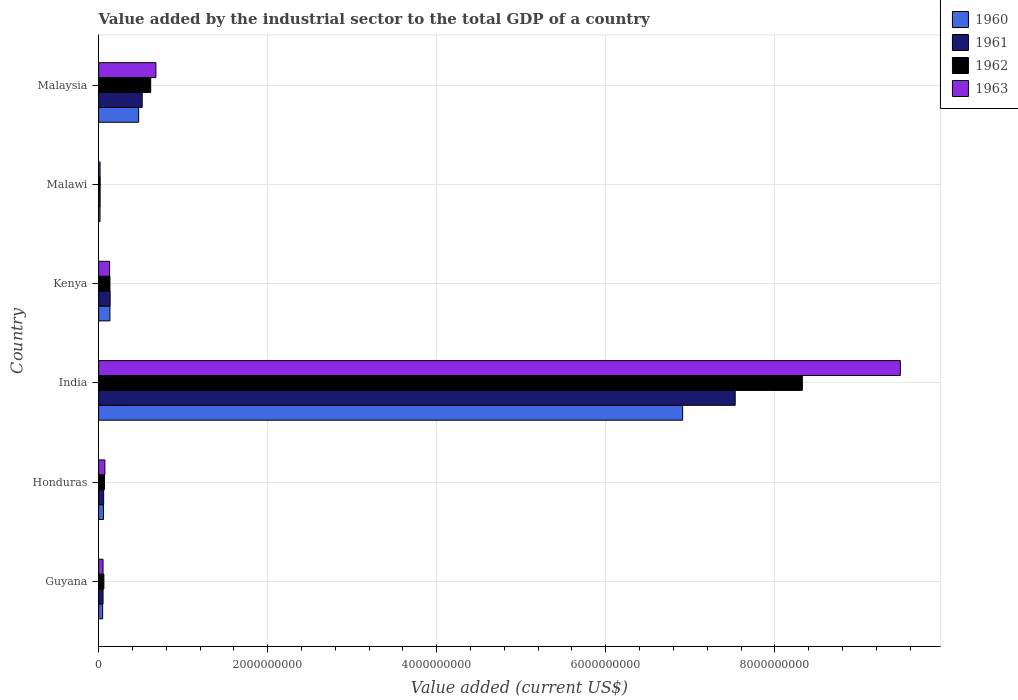How many different coloured bars are there?
Your response must be concise. 4. How many bars are there on the 1st tick from the top?
Give a very brief answer. 4. How many bars are there on the 1st tick from the bottom?
Make the answer very short. 4. What is the label of the 5th group of bars from the top?
Provide a short and direct response. Honduras. What is the value added by the industrial sector to the total GDP in 1962 in India?
Provide a short and direct response. 8.33e+09. Across all countries, what is the maximum value added by the industrial sector to the total GDP in 1962?
Offer a terse response. 8.33e+09. Across all countries, what is the minimum value added by the industrial sector to the total GDP in 1960?
Your answer should be compact. 1.62e+07. In which country was the value added by the industrial sector to the total GDP in 1960 minimum?
Your answer should be compact. Malawi. What is the total value added by the industrial sector to the total GDP in 1963 in the graph?
Provide a succinct answer. 1.04e+1. What is the difference between the value added by the industrial sector to the total GDP in 1962 in Guyana and that in Kenya?
Keep it short and to the point. -7.19e+07. What is the difference between the value added by the industrial sector to the total GDP in 1960 in Guyana and the value added by the industrial sector to the total GDP in 1962 in Honduras?
Ensure brevity in your answer.  -2.18e+07. What is the average value added by the industrial sector to the total GDP in 1961 per country?
Ensure brevity in your answer.  1.39e+09. What is the difference between the value added by the industrial sector to the total GDP in 1960 and value added by the industrial sector to the total GDP in 1962 in Malawi?
Your answer should be very brief. -1.54e+06. In how many countries, is the value added by the industrial sector to the total GDP in 1963 greater than 8400000000 US$?
Offer a terse response. 1. What is the ratio of the value added by the industrial sector to the total GDP in 1962 in Honduras to that in Malawi?
Offer a very short reply. 3.89. What is the difference between the highest and the second highest value added by the industrial sector to the total GDP in 1962?
Ensure brevity in your answer.  7.71e+09. What is the difference between the highest and the lowest value added by the industrial sector to the total GDP in 1962?
Provide a succinct answer. 8.31e+09. Is the sum of the value added by the industrial sector to the total GDP in 1960 in Kenya and Malaysia greater than the maximum value added by the industrial sector to the total GDP in 1963 across all countries?
Your answer should be very brief. No. What does the 3rd bar from the top in Malawi represents?
Provide a succinct answer. 1961. Is it the case that in every country, the sum of the value added by the industrial sector to the total GDP in 1960 and value added by the industrial sector to the total GDP in 1961 is greater than the value added by the industrial sector to the total GDP in 1963?
Make the answer very short. Yes. How many bars are there?
Make the answer very short. 24. Are all the bars in the graph horizontal?
Ensure brevity in your answer.  Yes. How many countries are there in the graph?
Give a very brief answer. 6. Are the values on the major ticks of X-axis written in scientific E-notation?
Provide a short and direct response. No. Where does the legend appear in the graph?
Your response must be concise. Top right. How many legend labels are there?
Ensure brevity in your answer.  4. What is the title of the graph?
Offer a very short reply. Value added by the industrial sector to the total GDP of a country. Does "1998" appear as one of the legend labels in the graph?
Keep it short and to the point. No. What is the label or title of the X-axis?
Offer a very short reply. Value added (current US$). What is the Value added (current US$) in 1960 in Guyana?
Your answer should be compact. 4.74e+07. What is the Value added (current US$) of 1961 in Guyana?
Give a very brief answer. 5.23e+07. What is the Value added (current US$) in 1962 in Guyana?
Provide a succinct answer. 6.20e+07. What is the Value added (current US$) in 1963 in Guyana?
Your answer should be compact. 5.21e+07. What is the Value added (current US$) in 1960 in Honduras?
Your answer should be very brief. 5.73e+07. What is the Value added (current US$) in 1961 in Honduras?
Offer a terse response. 5.94e+07. What is the Value added (current US$) in 1962 in Honduras?
Offer a very short reply. 6.92e+07. What is the Value added (current US$) in 1963 in Honduras?
Give a very brief answer. 7.38e+07. What is the Value added (current US$) of 1960 in India?
Provide a succinct answer. 6.91e+09. What is the Value added (current US$) in 1961 in India?
Ensure brevity in your answer.  7.53e+09. What is the Value added (current US$) in 1962 in India?
Provide a succinct answer. 8.33e+09. What is the Value added (current US$) of 1963 in India?
Provide a succinct answer. 9.49e+09. What is the Value added (current US$) in 1960 in Kenya?
Offer a very short reply. 1.34e+08. What is the Value added (current US$) in 1961 in Kenya?
Your response must be concise. 1.36e+08. What is the Value added (current US$) of 1962 in Kenya?
Your answer should be very brief. 1.34e+08. What is the Value added (current US$) in 1963 in Kenya?
Provide a succinct answer. 1.30e+08. What is the Value added (current US$) in 1960 in Malawi?
Provide a succinct answer. 1.62e+07. What is the Value added (current US$) of 1961 in Malawi?
Offer a terse response. 1.76e+07. What is the Value added (current US$) in 1962 in Malawi?
Provide a short and direct response. 1.78e+07. What is the Value added (current US$) in 1963 in Malawi?
Your answer should be very brief. 1.69e+07. What is the Value added (current US$) of 1960 in Malaysia?
Your answer should be very brief. 4.74e+08. What is the Value added (current US$) of 1961 in Malaysia?
Provide a succinct answer. 5.15e+08. What is the Value added (current US$) in 1962 in Malaysia?
Offer a very short reply. 6.16e+08. What is the Value added (current US$) in 1963 in Malaysia?
Offer a terse response. 6.77e+08. Across all countries, what is the maximum Value added (current US$) of 1960?
Provide a succinct answer. 6.91e+09. Across all countries, what is the maximum Value added (current US$) in 1961?
Make the answer very short. 7.53e+09. Across all countries, what is the maximum Value added (current US$) of 1962?
Offer a terse response. 8.33e+09. Across all countries, what is the maximum Value added (current US$) of 1963?
Ensure brevity in your answer.  9.49e+09. Across all countries, what is the minimum Value added (current US$) in 1960?
Keep it short and to the point. 1.62e+07. Across all countries, what is the minimum Value added (current US$) of 1961?
Ensure brevity in your answer.  1.76e+07. Across all countries, what is the minimum Value added (current US$) of 1962?
Your response must be concise. 1.78e+07. Across all countries, what is the minimum Value added (current US$) of 1963?
Keep it short and to the point. 1.69e+07. What is the total Value added (current US$) of 1960 in the graph?
Your answer should be compact. 7.64e+09. What is the total Value added (current US$) in 1961 in the graph?
Offer a terse response. 8.31e+09. What is the total Value added (current US$) of 1962 in the graph?
Keep it short and to the point. 9.22e+09. What is the total Value added (current US$) in 1963 in the graph?
Keep it short and to the point. 1.04e+1. What is the difference between the Value added (current US$) in 1960 in Guyana and that in Honduras?
Make the answer very short. -9.88e+06. What is the difference between the Value added (current US$) in 1961 in Guyana and that in Honduras?
Offer a terse response. -7.08e+06. What is the difference between the Value added (current US$) in 1962 in Guyana and that in Honduras?
Your answer should be very brief. -7.19e+06. What is the difference between the Value added (current US$) in 1963 in Guyana and that in Honduras?
Your answer should be very brief. -2.17e+07. What is the difference between the Value added (current US$) in 1960 in Guyana and that in India?
Provide a succinct answer. -6.86e+09. What is the difference between the Value added (current US$) in 1961 in Guyana and that in India?
Your answer should be very brief. -7.48e+09. What is the difference between the Value added (current US$) of 1962 in Guyana and that in India?
Provide a short and direct response. -8.26e+09. What is the difference between the Value added (current US$) of 1963 in Guyana and that in India?
Provide a short and direct response. -9.43e+09. What is the difference between the Value added (current US$) of 1960 in Guyana and that in Kenya?
Your answer should be very brief. -8.62e+07. What is the difference between the Value added (current US$) in 1961 in Guyana and that in Kenya?
Offer a terse response. -8.36e+07. What is the difference between the Value added (current US$) in 1962 in Guyana and that in Kenya?
Your answer should be compact. -7.19e+07. What is the difference between the Value added (current US$) in 1963 in Guyana and that in Kenya?
Give a very brief answer. -7.74e+07. What is the difference between the Value added (current US$) of 1960 in Guyana and that in Malawi?
Make the answer very short. 3.12e+07. What is the difference between the Value added (current US$) in 1961 in Guyana and that in Malawi?
Give a very brief answer. 3.46e+07. What is the difference between the Value added (current US$) in 1962 in Guyana and that in Malawi?
Ensure brevity in your answer.  4.42e+07. What is the difference between the Value added (current US$) in 1963 in Guyana and that in Malawi?
Provide a short and direct response. 3.52e+07. What is the difference between the Value added (current US$) in 1960 in Guyana and that in Malaysia?
Your response must be concise. -4.26e+08. What is the difference between the Value added (current US$) of 1961 in Guyana and that in Malaysia?
Offer a very short reply. -4.63e+08. What is the difference between the Value added (current US$) of 1962 in Guyana and that in Malaysia?
Your answer should be very brief. -5.54e+08. What is the difference between the Value added (current US$) of 1963 in Guyana and that in Malaysia?
Give a very brief answer. -6.25e+08. What is the difference between the Value added (current US$) of 1960 in Honduras and that in India?
Your response must be concise. -6.85e+09. What is the difference between the Value added (current US$) of 1961 in Honduras and that in India?
Provide a succinct answer. -7.47e+09. What is the difference between the Value added (current US$) in 1962 in Honduras and that in India?
Ensure brevity in your answer.  -8.26e+09. What is the difference between the Value added (current US$) of 1963 in Honduras and that in India?
Make the answer very short. -9.41e+09. What is the difference between the Value added (current US$) of 1960 in Honduras and that in Kenya?
Provide a short and direct response. -7.63e+07. What is the difference between the Value added (current US$) in 1961 in Honduras and that in Kenya?
Ensure brevity in your answer.  -7.65e+07. What is the difference between the Value added (current US$) in 1962 in Honduras and that in Kenya?
Offer a terse response. -6.47e+07. What is the difference between the Value added (current US$) of 1963 in Honduras and that in Kenya?
Make the answer very short. -5.57e+07. What is the difference between the Value added (current US$) in 1960 in Honduras and that in Malawi?
Ensure brevity in your answer.  4.11e+07. What is the difference between the Value added (current US$) in 1961 in Honduras and that in Malawi?
Ensure brevity in your answer.  4.17e+07. What is the difference between the Value added (current US$) of 1962 in Honduras and that in Malawi?
Your answer should be compact. 5.14e+07. What is the difference between the Value added (current US$) in 1963 in Honduras and that in Malawi?
Provide a short and direct response. 5.69e+07. What is the difference between the Value added (current US$) of 1960 in Honduras and that in Malaysia?
Provide a short and direct response. -4.16e+08. What is the difference between the Value added (current US$) of 1961 in Honduras and that in Malaysia?
Give a very brief answer. -4.56e+08. What is the difference between the Value added (current US$) of 1962 in Honduras and that in Malaysia?
Your answer should be compact. -5.47e+08. What is the difference between the Value added (current US$) in 1963 in Honduras and that in Malaysia?
Offer a terse response. -6.04e+08. What is the difference between the Value added (current US$) in 1960 in India and that in Kenya?
Give a very brief answer. 6.78e+09. What is the difference between the Value added (current US$) of 1961 in India and that in Kenya?
Keep it short and to the point. 7.40e+09. What is the difference between the Value added (current US$) of 1962 in India and that in Kenya?
Ensure brevity in your answer.  8.19e+09. What is the difference between the Value added (current US$) of 1963 in India and that in Kenya?
Make the answer very short. 9.36e+09. What is the difference between the Value added (current US$) of 1960 in India and that in Malawi?
Your response must be concise. 6.89e+09. What is the difference between the Value added (current US$) in 1961 in India and that in Malawi?
Keep it short and to the point. 7.51e+09. What is the difference between the Value added (current US$) in 1962 in India and that in Malawi?
Offer a very short reply. 8.31e+09. What is the difference between the Value added (current US$) of 1963 in India and that in Malawi?
Provide a short and direct response. 9.47e+09. What is the difference between the Value added (current US$) in 1960 in India and that in Malaysia?
Ensure brevity in your answer.  6.44e+09. What is the difference between the Value added (current US$) in 1961 in India and that in Malaysia?
Offer a very short reply. 7.02e+09. What is the difference between the Value added (current US$) in 1962 in India and that in Malaysia?
Ensure brevity in your answer.  7.71e+09. What is the difference between the Value added (current US$) in 1963 in India and that in Malaysia?
Make the answer very short. 8.81e+09. What is the difference between the Value added (current US$) of 1960 in Kenya and that in Malawi?
Make the answer very short. 1.17e+08. What is the difference between the Value added (current US$) of 1961 in Kenya and that in Malawi?
Keep it short and to the point. 1.18e+08. What is the difference between the Value added (current US$) of 1962 in Kenya and that in Malawi?
Make the answer very short. 1.16e+08. What is the difference between the Value added (current US$) of 1963 in Kenya and that in Malawi?
Your answer should be compact. 1.13e+08. What is the difference between the Value added (current US$) in 1960 in Kenya and that in Malaysia?
Give a very brief answer. -3.40e+08. What is the difference between the Value added (current US$) in 1961 in Kenya and that in Malaysia?
Offer a very short reply. -3.79e+08. What is the difference between the Value added (current US$) of 1962 in Kenya and that in Malaysia?
Keep it short and to the point. -4.82e+08. What is the difference between the Value added (current US$) in 1963 in Kenya and that in Malaysia?
Your answer should be compact. -5.48e+08. What is the difference between the Value added (current US$) of 1960 in Malawi and that in Malaysia?
Your response must be concise. -4.57e+08. What is the difference between the Value added (current US$) of 1961 in Malawi and that in Malaysia?
Ensure brevity in your answer.  -4.98e+08. What is the difference between the Value added (current US$) of 1962 in Malawi and that in Malaysia?
Make the answer very short. -5.98e+08. What is the difference between the Value added (current US$) of 1963 in Malawi and that in Malaysia?
Make the answer very short. -6.61e+08. What is the difference between the Value added (current US$) in 1960 in Guyana and the Value added (current US$) in 1961 in Honduras?
Ensure brevity in your answer.  -1.19e+07. What is the difference between the Value added (current US$) of 1960 in Guyana and the Value added (current US$) of 1962 in Honduras?
Make the answer very short. -2.18e+07. What is the difference between the Value added (current US$) in 1960 in Guyana and the Value added (current US$) in 1963 in Honduras?
Your answer should be very brief. -2.64e+07. What is the difference between the Value added (current US$) in 1961 in Guyana and the Value added (current US$) in 1962 in Honduras?
Your answer should be very brief. -1.69e+07. What is the difference between the Value added (current US$) in 1961 in Guyana and the Value added (current US$) in 1963 in Honduras?
Your response must be concise. -2.15e+07. What is the difference between the Value added (current US$) in 1962 in Guyana and the Value added (current US$) in 1963 in Honduras?
Keep it short and to the point. -1.18e+07. What is the difference between the Value added (current US$) in 1960 in Guyana and the Value added (current US$) in 1961 in India?
Offer a terse response. -7.48e+09. What is the difference between the Value added (current US$) in 1960 in Guyana and the Value added (current US$) in 1962 in India?
Provide a succinct answer. -8.28e+09. What is the difference between the Value added (current US$) in 1960 in Guyana and the Value added (current US$) in 1963 in India?
Your response must be concise. -9.44e+09. What is the difference between the Value added (current US$) in 1961 in Guyana and the Value added (current US$) in 1962 in India?
Give a very brief answer. -8.27e+09. What is the difference between the Value added (current US$) of 1961 in Guyana and the Value added (current US$) of 1963 in India?
Provide a succinct answer. -9.43e+09. What is the difference between the Value added (current US$) in 1962 in Guyana and the Value added (current US$) in 1963 in India?
Make the answer very short. -9.42e+09. What is the difference between the Value added (current US$) of 1960 in Guyana and the Value added (current US$) of 1961 in Kenya?
Provide a succinct answer. -8.85e+07. What is the difference between the Value added (current US$) in 1960 in Guyana and the Value added (current US$) in 1962 in Kenya?
Offer a very short reply. -8.65e+07. What is the difference between the Value added (current US$) in 1960 in Guyana and the Value added (current US$) in 1963 in Kenya?
Offer a terse response. -8.21e+07. What is the difference between the Value added (current US$) of 1961 in Guyana and the Value added (current US$) of 1962 in Kenya?
Offer a very short reply. -8.17e+07. What is the difference between the Value added (current US$) of 1961 in Guyana and the Value added (current US$) of 1963 in Kenya?
Your response must be concise. -7.73e+07. What is the difference between the Value added (current US$) in 1962 in Guyana and the Value added (current US$) in 1963 in Kenya?
Offer a terse response. -6.75e+07. What is the difference between the Value added (current US$) of 1960 in Guyana and the Value added (current US$) of 1961 in Malawi?
Ensure brevity in your answer.  2.98e+07. What is the difference between the Value added (current US$) in 1960 in Guyana and the Value added (current US$) in 1962 in Malawi?
Offer a very short reply. 2.96e+07. What is the difference between the Value added (current US$) of 1960 in Guyana and the Value added (current US$) of 1963 in Malawi?
Offer a terse response. 3.05e+07. What is the difference between the Value added (current US$) in 1961 in Guyana and the Value added (current US$) in 1962 in Malawi?
Give a very brief answer. 3.45e+07. What is the difference between the Value added (current US$) of 1961 in Guyana and the Value added (current US$) of 1963 in Malawi?
Provide a short and direct response. 3.53e+07. What is the difference between the Value added (current US$) of 1962 in Guyana and the Value added (current US$) of 1963 in Malawi?
Offer a terse response. 4.51e+07. What is the difference between the Value added (current US$) of 1960 in Guyana and the Value added (current US$) of 1961 in Malaysia?
Give a very brief answer. -4.68e+08. What is the difference between the Value added (current US$) in 1960 in Guyana and the Value added (current US$) in 1962 in Malaysia?
Provide a short and direct response. -5.69e+08. What is the difference between the Value added (current US$) of 1960 in Guyana and the Value added (current US$) of 1963 in Malaysia?
Provide a succinct answer. -6.30e+08. What is the difference between the Value added (current US$) in 1961 in Guyana and the Value added (current US$) in 1962 in Malaysia?
Ensure brevity in your answer.  -5.64e+08. What is the difference between the Value added (current US$) of 1961 in Guyana and the Value added (current US$) of 1963 in Malaysia?
Offer a terse response. -6.25e+08. What is the difference between the Value added (current US$) of 1962 in Guyana and the Value added (current US$) of 1963 in Malaysia?
Offer a very short reply. -6.15e+08. What is the difference between the Value added (current US$) in 1960 in Honduras and the Value added (current US$) in 1961 in India?
Offer a very short reply. -7.47e+09. What is the difference between the Value added (current US$) of 1960 in Honduras and the Value added (current US$) of 1962 in India?
Provide a short and direct response. -8.27e+09. What is the difference between the Value added (current US$) in 1960 in Honduras and the Value added (current US$) in 1963 in India?
Your response must be concise. -9.43e+09. What is the difference between the Value added (current US$) in 1961 in Honduras and the Value added (current US$) in 1962 in India?
Offer a terse response. -8.27e+09. What is the difference between the Value added (current US$) of 1961 in Honduras and the Value added (current US$) of 1963 in India?
Offer a terse response. -9.43e+09. What is the difference between the Value added (current US$) in 1962 in Honduras and the Value added (current US$) in 1963 in India?
Provide a succinct answer. -9.42e+09. What is the difference between the Value added (current US$) in 1960 in Honduras and the Value added (current US$) in 1961 in Kenya?
Ensure brevity in your answer.  -7.86e+07. What is the difference between the Value added (current US$) in 1960 in Honduras and the Value added (current US$) in 1962 in Kenya?
Keep it short and to the point. -7.66e+07. What is the difference between the Value added (current US$) of 1960 in Honduras and the Value added (current US$) of 1963 in Kenya?
Your response must be concise. -7.22e+07. What is the difference between the Value added (current US$) of 1961 in Honduras and the Value added (current US$) of 1962 in Kenya?
Give a very brief answer. -7.46e+07. What is the difference between the Value added (current US$) in 1961 in Honduras and the Value added (current US$) in 1963 in Kenya?
Provide a short and direct response. -7.02e+07. What is the difference between the Value added (current US$) of 1962 in Honduras and the Value added (current US$) of 1963 in Kenya?
Give a very brief answer. -6.03e+07. What is the difference between the Value added (current US$) of 1960 in Honduras and the Value added (current US$) of 1961 in Malawi?
Provide a succinct answer. 3.97e+07. What is the difference between the Value added (current US$) in 1960 in Honduras and the Value added (current US$) in 1962 in Malawi?
Make the answer very short. 3.95e+07. What is the difference between the Value added (current US$) of 1960 in Honduras and the Value added (current US$) of 1963 in Malawi?
Offer a terse response. 4.04e+07. What is the difference between the Value added (current US$) in 1961 in Honduras and the Value added (current US$) in 1962 in Malawi?
Your answer should be compact. 4.16e+07. What is the difference between the Value added (current US$) in 1961 in Honduras and the Value added (current US$) in 1963 in Malawi?
Ensure brevity in your answer.  4.24e+07. What is the difference between the Value added (current US$) in 1962 in Honduras and the Value added (current US$) in 1963 in Malawi?
Offer a very short reply. 5.23e+07. What is the difference between the Value added (current US$) of 1960 in Honduras and the Value added (current US$) of 1961 in Malaysia?
Make the answer very short. -4.58e+08. What is the difference between the Value added (current US$) in 1960 in Honduras and the Value added (current US$) in 1962 in Malaysia?
Your answer should be compact. -5.59e+08. What is the difference between the Value added (current US$) in 1960 in Honduras and the Value added (current US$) in 1963 in Malaysia?
Ensure brevity in your answer.  -6.20e+08. What is the difference between the Value added (current US$) of 1961 in Honduras and the Value added (current US$) of 1962 in Malaysia?
Offer a very short reply. -5.57e+08. What is the difference between the Value added (current US$) of 1961 in Honduras and the Value added (current US$) of 1963 in Malaysia?
Provide a short and direct response. -6.18e+08. What is the difference between the Value added (current US$) in 1962 in Honduras and the Value added (current US$) in 1963 in Malaysia?
Give a very brief answer. -6.08e+08. What is the difference between the Value added (current US$) in 1960 in India and the Value added (current US$) in 1961 in Kenya?
Keep it short and to the point. 6.77e+09. What is the difference between the Value added (current US$) in 1960 in India and the Value added (current US$) in 1962 in Kenya?
Offer a very short reply. 6.78e+09. What is the difference between the Value added (current US$) in 1960 in India and the Value added (current US$) in 1963 in Kenya?
Your answer should be very brief. 6.78e+09. What is the difference between the Value added (current US$) of 1961 in India and the Value added (current US$) of 1962 in Kenya?
Make the answer very short. 7.40e+09. What is the difference between the Value added (current US$) in 1961 in India and the Value added (current US$) in 1963 in Kenya?
Your answer should be very brief. 7.40e+09. What is the difference between the Value added (current US$) in 1962 in India and the Value added (current US$) in 1963 in Kenya?
Your response must be concise. 8.20e+09. What is the difference between the Value added (current US$) of 1960 in India and the Value added (current US$) of 1961 in Malawi?
Your response must be concise. 6.89e+09. What is the difference between the Value added (current US$) in 1960 in India and the Value added (current US$) in 1962 in Malawi?
Your answer should be very brief. 6.89e+09. What is the difference between the Value added (current US$) in 1960 in India and the Value added (current US$) in 1963 in Malawi?
Your response must be concise. 6.89e+09. What is the difference between the Value added (current US$) of 1961 in India and the Value added (current US$) of 1962 in Malawi?
Ensure brevity in your answer.  7.51e+09. What is the difference between the Value added (current US$) in 1961 in India and the Value added (current US$) in 1963 in Malawi?
Your answer should be compact. 7.51e+09. What is the difference between the Value added (current US$) of 1962 in India and the Value added (current US$) of 1963 in Malawi?
Your response must be concise. 8.31e+09. What is the difference between the Value added (current US$) in 1960 in India and the Value added (current US$) in 1961 in Malaysia?
Ensure brevity in your answer.  6.39e+09. What is the difference between the Value added (current US$) of 1960 in India and the Value added (current US$) of 1962 in Malaysia?
Your answer should be compact. 6.29e+09. What is the difference between the Value added (current US$) in 1960 in India and the Value added (current US$) in 1963 in Malaysia?
Provide a succinct answer. 6.23e+09. What is the difference between the Value added (current US$) of 1961 in India and the Value added (current US$) of 1962 in Malaysia?
Provide a short and direct response. 6.92e+09. What is the difference between the Value added (current US$) of 1961 in India and the Value added (current US$) of 1963 in Malaysia?
Ensure brevity in your answer.  6.85e+09. What is the difference between the Value added (current US$) of 1962 in India and the Value added (current US$) of 1963 in Malaysia?
Offer a very short reply. 7.65e+09. What is the difference between the Value added (current US$) of 1960 in Kenya and the Value added (current US$) of 1961 in Malawi?
Offer a terse response. 1.16e+08. What is the difference between the Value added (current US$) of 1960 in Kenya and the Value added (current US$) of 1962 in Malawi?
Offer a terse response. 1.16e+08. What is the difference between the Value added (current US$) in 1960 in Kenya and the Value added (current US$) in 1963 in Malawi?
Your answer should be compact. 1.17e+08. What is the difference between the Value added (current US$) of 1961 in Kenya and the Value added (current US$) of 1962 in Malawi?
Offer a very short reply. 1.18e+08. What is the difference between the Value added (current US$) in 1961 in Kenya and the Value added (current US$) in 1963 in Malawi?
Give a very brief answer. 1.19e+08. What is the difference between the Value added (current US$) in 1962 in Kenya and the Value added (current US$) in 1963 in Malawi?
Offer a terse response. 1.17e+08. What is the difference between the Value added (current US$) of 1960 in Kenya and the Value added (current US$) of 1961 in Malaysia?
Provide a short and direct response. -3.82e+08. What is the difference between the Value added (current US$) of 1960 in Kenya and the Value added (current US$) of 1962 in Malaysia?
Keep it short and to the point. -4.82e+08. What is the difference between the Value added (current US$) of 1960 in Kenya and the Value added (current US$) of 1963 in Malaysia?
Offer a terse response. -5.44e+08. What is the difference between the Value added (current US$) of 1961 in Kenya and the Value added (current US$) of 1962 in Malaysia?
Provide a short and direct response. -4.80e+08. What is the difference between the Value added (current US$) of 1961 in Kenya and the Value added (current US$) of 1963 in Malaysia?
Ensure brevity in your answer.  -5.42e+08. What is the difference between the Value added (current US$) of 1962 in Kenya and the Value added (current US$) of 1963 in Malaysia?
Ensure brevity in your answer.  -5.44e+08. What is the difference between the Value added (current US$) of 1960 in Malawi and the Value added (current US$) of 1961 in Malaysia?
Provide a succinct answer. -4.99e+08. What is the difference between the Value added (current US$) of 1960 in Malawi and the Value added (current US$) of 1962 in Malaysia?
Offer a very short reply. -6.00e+08. What is the difference between the Value added (current US$) of 1960 in Malawi and the Value added (current US$) of 1963 in Malaysia?
Offer a very short reply. -6.61e+08. What is the difference between the Value added (current US$) of 1961 in Malawi and the Value added (current US$) of 1962 in Malaysia?
Ensure brevity in your answer.  -5.98e+08. What is the difference between the Value added (current US$) of 1961 in Malawi and the Value added (current US$) of 1963 in Malaysia?
Provide a succinct answer. -6.60e+08. What is the difference between the Value added (current US$) in 1962 in Malawi and the Value added (current US$) in 1963 in Malaysia?
Offer a very short reply. -6.60e+08. What is the average Value added (current US$) of 1960 per country?
Your answer should be compact. 1.27e+09. What is the average Value added (current US$) of 1961 per country?
Provide a short and direct response. 1.39e+09. What is the average Value added (current US$) of 1962 per country?
Provide a short and direct response. 1.54e+09. What is the average Value added (current US$) of 1963 per country?
Ensure brevity in your answer.  1.74e+09. What is the difference between the Value added (current US$) in 1960 and Value added (current US$) in 1961 in Guyana?
Ensure brevity in your answer.  -4.84e+06. What is the difference between the Value added (current US$) of 1960 and Value added (current US$) of 1962 in Guyana?
Your answer should be very brief. -1.46e+07. What is the difference between the Value added (current US$) of 1960 and Value added (current US$) of 1963 in Guyana?
Your answer should be very brief. -4.67e+06. What is the difference between the Value added (current US$) of 1961 and Value added (current US$) of 1962 in Guyana?
Make the answer very short. -9.74e+06. What is the difference between the Value added (current US$) in 1961 and Value added (current US$) in 1963 in Guyana?
Offer a very short reply. 1.75e+05. What is the difference between the Value added (current US$) of 1962 and Value added (current US$) of 1963 in Guyana?
Offer a very short reply. 9.92e+06. What is the difference between the Value added (current US$) of 1960 and Value added (current US$) of 1961 in Honduras?
Give a very brief answer. -2.05e+06. What is the difference between the Value added (current US$) of 1960 and Value added (current US$) of 1962 in Honduras?
Your answer should be compact. -1.19e+07. What is the difference between the Value added (current US$) of 1960 and Value added (current US$) of 1963 in Honduras?
Provide a short and direct response. -1.65e+07. What is the difference between the Value added (current US$) of 1961 and Value added (current US$) of 1962 in Honduras?
Give a very brief answer. -9.85e+06. What is the difference between the Value added (current US$) in 1961 and Value added (current US$) in 1963 in Honduras?
Your response must be concise. -1.44e+07. What is the difference between the Value added (current US$) in 1962 and Value added (current US$) in 1963 in Honduras?
Offer a terse response. -4.60e+06. What is the difference between the Value added (current US$) of 1960 and Value added (current US$) of 1961 in India?
Keep it short and to the point. -6.21e+08. What is the difference between the Value added (current US$) in 1960 and Value added (current US$) in 1962 in India?
Provide a short and direct response. -1.42e+09. What is the difference between the Value added (current US$) in 1960 and Value added (current US$) in 1963 in India?
Your answer should be very brief. -2.58e+09. What is the difference between the Value added (current US$) in 1961 and Value added (current US$) in 1962 in India?
Keep it short and to the point. -7.94e+08. What is the difference between the Value added (current US$) in 1961 and Value added (current US$) in 1963 in India?
Keep it short and to the point. -1.95e+09. What is the difference between the Value added (current US$) of 1962 and Value added (current US$) of 1963 in India?
Your answer should be very brief. -1.16e+09. What is the difference between the Value added (current US$) of 1960 and Value added (current US$) of 1961 in Kenya?
Give a very brief answer. -2.25e+06. What is the difference between the Value added (current US$) of 1960 and Value added (current US$) of 1962 in Kenya?
Offer a very short reply. -2.94e+05. What is the difference between the Value added (current US$) in 1960 and Value added (current US$) in 1963 in Kenya?
Give a very brief answer. 4.12e+06. What is the difference between the Value added (current US$) in 1961 and Value added (current US$) in 1962 in Kenya?
Offer a very short reply. 1.96e+06. What is the difference between the Value added (current US$) of 1961 and Value added (current US$) of 1963 in Kenya?
Offer a very short reply. 6.37e+06. What is the difference between the Value added (current US$) of 1962 and Value added (current US$) of 1963 in Kenya?
Make the answer very short. 4.41e+06. What is the difference between the Value added (current US$) in 1960 and Value added (current US$) in 1961 in Malawi?
Offer a terse response. -1.40e+06. What is the difference between the Value added (current US$) of 1960 and Value added (current US$) of 1962 in Malawi?
Offer a terse response. -1.54e+06. What is the difference between the Value added (current US$) of 1960 and Value added (current US$) of 1963 in Malawi?
Your response must be concise. -7.00e+05. What is the difference between the Value added (current US$) of 1961 and Value added (current US$) of 1962 in Malawi?
Your response must be concise. -1.40e+05. What is the difference between the Value added (current US$) of 1961 and Value added (current US$) of 1963 in Malawi?
Provide a succinct answer. 7.00e+05. What is the difference between the Value added (current US$) of 1962 and Value added (current US$) of 1963 in Malawi?
Your answer should be very brief. 8.40e+05. What is the difference between the Value added (current US$) in 1960 and Value added (current US$) in 1961 in Malaysia?
Your answer should be compact. -4.19e+07. What is the difference between the Value added (current US$) in 1960 and Value added (current US$) in 1962 in Malaysia?
Provide a succinct answer. -1.43e+08. What is the difference between the Value added (current US$) in 1960 and Value added (current US$) in 1963 in Malaysia?
Your response must be concise. -2.04e+08. What is the difference between the Value added (current US$) in 1961 and Value added (current US$) in 1962 in Malaysia?
Keep it short and to the point. -1.01e+08. What is the difference between the Value added (current US$) of 1961 and Value added (current US$) of 1963 in Malaysia?
Offer a very short reply. -1.62e+08. What is the difference between the Value added (current US$) of 1962 and Value added (current US$) of 1963 in Malaysia?
Make the answer very short. -6.14e+07. What is the ratio of the Value added (current US$) in 1960 in Guyana to that in Honduras?
Your answer should be compact. 0.83. What is the ratio of the Value added (current US$) in 1961 in Guyana to that in Honduras?
Your answer should be compact. 0.88. What is the ratio of the Value added (current US$) of 1962 in Guyana to that in Honduras?
Offer a terse response. 0.9. What is the ratio of the Value added (current US$) in 1963 in Guyana to that in Honduras?
Provide a short and direct response. 0.71. What is the ratio of the Value added (current US$) of 1960 in Guyana to that in India?
Give a very brief answer. 0.01. What is the ratio of the Value added (current US$) of 1961 in Guyana to that in India?
Offer a very short reply. 0.01. What is the ratio of the Value added (current US$) of 1962 in Guyana to that in India?
Keep it short and to the point. 0.01. What is the ratio of the Value added (current US$) of 1963 in Guyana to that in India?
Offer a terse response. 0.01. What is the ratio of the Value added (current US$) in 1960 in Guyana to that in Kenya?
Your answer should be compact. 0.35. What is the ratio of the Value added (current US$) of 1961 in Guyana to that in Kenya?
Offer a terse response. 0.38. What is the ratio of the Value added (current US$) of 1962 in Guyana to that in Kenya?
Ensure brevity in your answer.  0.46. What is the ratio of the Value added (current US$) of 1963 in Guyana to that in Kenya?
Offer a terse response. 0.4. What is the ratio of the Value added (current US$) of 1960 in Guyana to that in Malawi?
Offer a terse response. 2.92. What is the ratio of the Value added (current US$) of 1961 in Guyana to that in Malawi?
Provide a short and direct response. 2.96. What is the ratio of the Value added (current US$) in 1962 in Guyana to that in Malawi?
Provide a short and direct response. 3.49. What is the ratio of the Value added (current US$) of 1963 in Guyana to that in Malawi?
Give a very brief answer. 3.08. What is the ratio of the Value added (current US$) of 1960 in Guyana to that in Malaysia?
Provide a succinct answer. 0.1. What is the ratio of the Value added (current US$) of 1961 in Guyana to that in Malaysia?
Your answer should be very brief. 0.1. What is the ratio of the Value added (current US$) in 1962 in Guyana to that in Malaysia?
Provide a short and direct response. 0.1. What is the ratio of the Value added (current US$) of 1963 in Guyana to that in Malaysia?
Offer a very short reply. 0.08. What is the ratio of the Value added (current US$) in 1960 in Honduras to that in India?
Keep it short and to the point. 0.01. What is the ratio of the Value added (current US$) of 1961 in Honduras to that in India?
Make the answer very short. 0.01. What is the ratio of the Value added (current US$) of 1962 in Honduras to that in India?
Give a very brief answer. 0.01. What is the ratio of the Value added (current US$) of 1963 in Honduras to that in India?
Ensure brevity in your answer.  0.01. What is the ratio of the Value added (current US$) in 1960 in Honduras to that in Kenya?
Your response must be concise. 0.43. What is the ratio of the Value added (current US$) in 1961 in Honduras to that in Kenya?
Provide a short and direct response. 0.44. What is the ratio of the Value added (current US$) in 1962 in Honduras to that in Kenya?
Keep it short and to the point. 0.52. What is the ratio of the Value added (current US$) of 1963 in Honduras to that in Kenya?
Keep it short and to the point. 0.57. What is the ratio of the Value added (current US$) in 1960 in Honduras to that in Malawi?
Ensure brevity in your answer.  3.53. What is the ratio of the Value added (current US$) of 1961 in Honduras to that in Malawi?
Your answer should be very brief. 3.36. What is the ratio of the Value added (current US$) of 1962 in Honduras to that in Malawi?
Ensure brevity in your answer.  3.89. What is the ratio of the Value added (current US$) of 1963 in Honduras to that in Malawi?
Provide a succinct answer. 4.36. What is the ratio of the Value added (current US$) in 1960 in Honduras to that in Malaysia?
Make the answer very short. 0.12. What is the ratio of the Value added (current US$) of 1961 in Honduras to that in Malaysia?
Make the answer very short. 0.12. What is the ratio of the Value added (current US$) in 1962 in Honduras to that in Malaysia?
Your answer should be compact. 0.11. What is the ratio of the Value added (current US$) of 1963 in Honduras to that in Malaysia?
Keep it short and to the point. 0.11. What is the ratio of the Value added (current US$) in 1960 in India to that in Kenya?
Give a very brief answer. 51.7. What is the ratio of the Value added (current US$) in 1961 in India to that in Kenya?
Ensure brevity in your answer.  55.42. What is the ratio of the Value added (current US$) in 1962 in India to that in Kenya?
Provide a succinct answer. 62.16. What is the ratio of the Value added (current US$) in 1963 in India to that in Kenya?
Offer a very short reply. 73.23. What is the ratio of the Value added (current US$) in 1960 in India to that in Malawi?
Your answer should be compact. 425.49. What is the ratio of the Value added (current US$) of 1961 in India to that in Malawi?
Offer a terse response. 426.94. What is the ratio of the Value added (current US$) in 1962 in India to that in Malawi?
Keep it short and to the point. 468.26. What is the ratio of the Value added (current US$) in 1963 in India to that in Malawi?
Provide a succinct answer. 559.94. What is the ratio of the Value added (current US$) in 1960 in India to that in Malaysia?
Your response must be concise. 14.59. What is the ratio of the Value added (current US$) of 1961 in India to that in Malaysia?
Your answer should be very brief. 14.61. What is the ratio of the Value added (current US$) of 1962 in India to that in Malaysia?
Provide a short and direct response. 13.51. What is the ratio of the Value added (current US$) of 1963 in India to that in Malaysia?
Ensure brevity in your answer.  14. What is the ratio of the Value added (current US$) in 1960 in Kenya to that in Malawi?
Keep it short and to the point. 8.23. What is the ratio of the Value added (current US$) in 1961 in Kenya to that in Malawi?
Keep it short and to the point. 7.7. What is the ratio of the Value added (current US$) in 1962 in Kenya to that in Malawi?
Your answer should be compact. 7.53. What is the ratio of the Value added (current US$) of 1963 in Kenya to that in Malawi?
Keep it short and to the point. 7.65. What is the ratio of the Value added (current US$) in 1960 in Kenya to that in Malaysia?
Your response must be concise. 0.28. What is the ratio of the Value added (current US$) of 1961 in Kenya to that in Malaysia?
Keep it short and to the point. 0.26. What is the ratio of the Value added (current US$) in 1962 in Kenya to that in Malaysia?
Provide a short and direct response. 0.22. What is the ratio of the Value added (current US$) in 1963 in Kenya to that in Malaysia?
Your answer should be very brief. 0.19. What is the ratio of the Value added (current US$) of 1960 in Malawi to that in Malaysia?
Your answer should be very brief. 0.03. What is the ratio of the Value added (current US$) of 1961 in Malawi to that in Malaysia?
Give a very brief answer. 0.03. What is the ratio of the Value added (current US$) in 1962 in Malawi to that in Malaysia?
Offer a terse response. 0.03. What is the ratio of the Value added (current US$) of 1963 in Malawi to that in Malaysia?
Provide a succinct answer. 0.03. What is the difference between the highest and the second highest Value added (current US$) in 1960?
Provide a short and direct response. 6.44e+09. What is the difference between the highest and the second highest Value added (current US$) in 1961?
Provide a succinct answer. 7.02e+09. What is the difference between the highest and the second highest Value added (current US$) in 1962?
Provide a short and direct response. 7.71e+09. What is the difference between the highest and the second highest Value added (current US$) in 1963?
Keep it short and to the point. 8.81e+09. What is the difference between the highest and the lowest Value added (current US$) in 1960?
Make the answer very short. 6.89e+09. What is the difference between the highest and the lowest Value added (current US$) in 1961?
Your answer should be compact. 7.51e+09. What is the difference between the highest and the lowest Value added (current US$) of 1962?
Make the answer very short. 8.31e+09. What is the difference between the highest and the lowest Value added (current US$) of 1963?
Provide a succinct answer. 9.47e+09. 